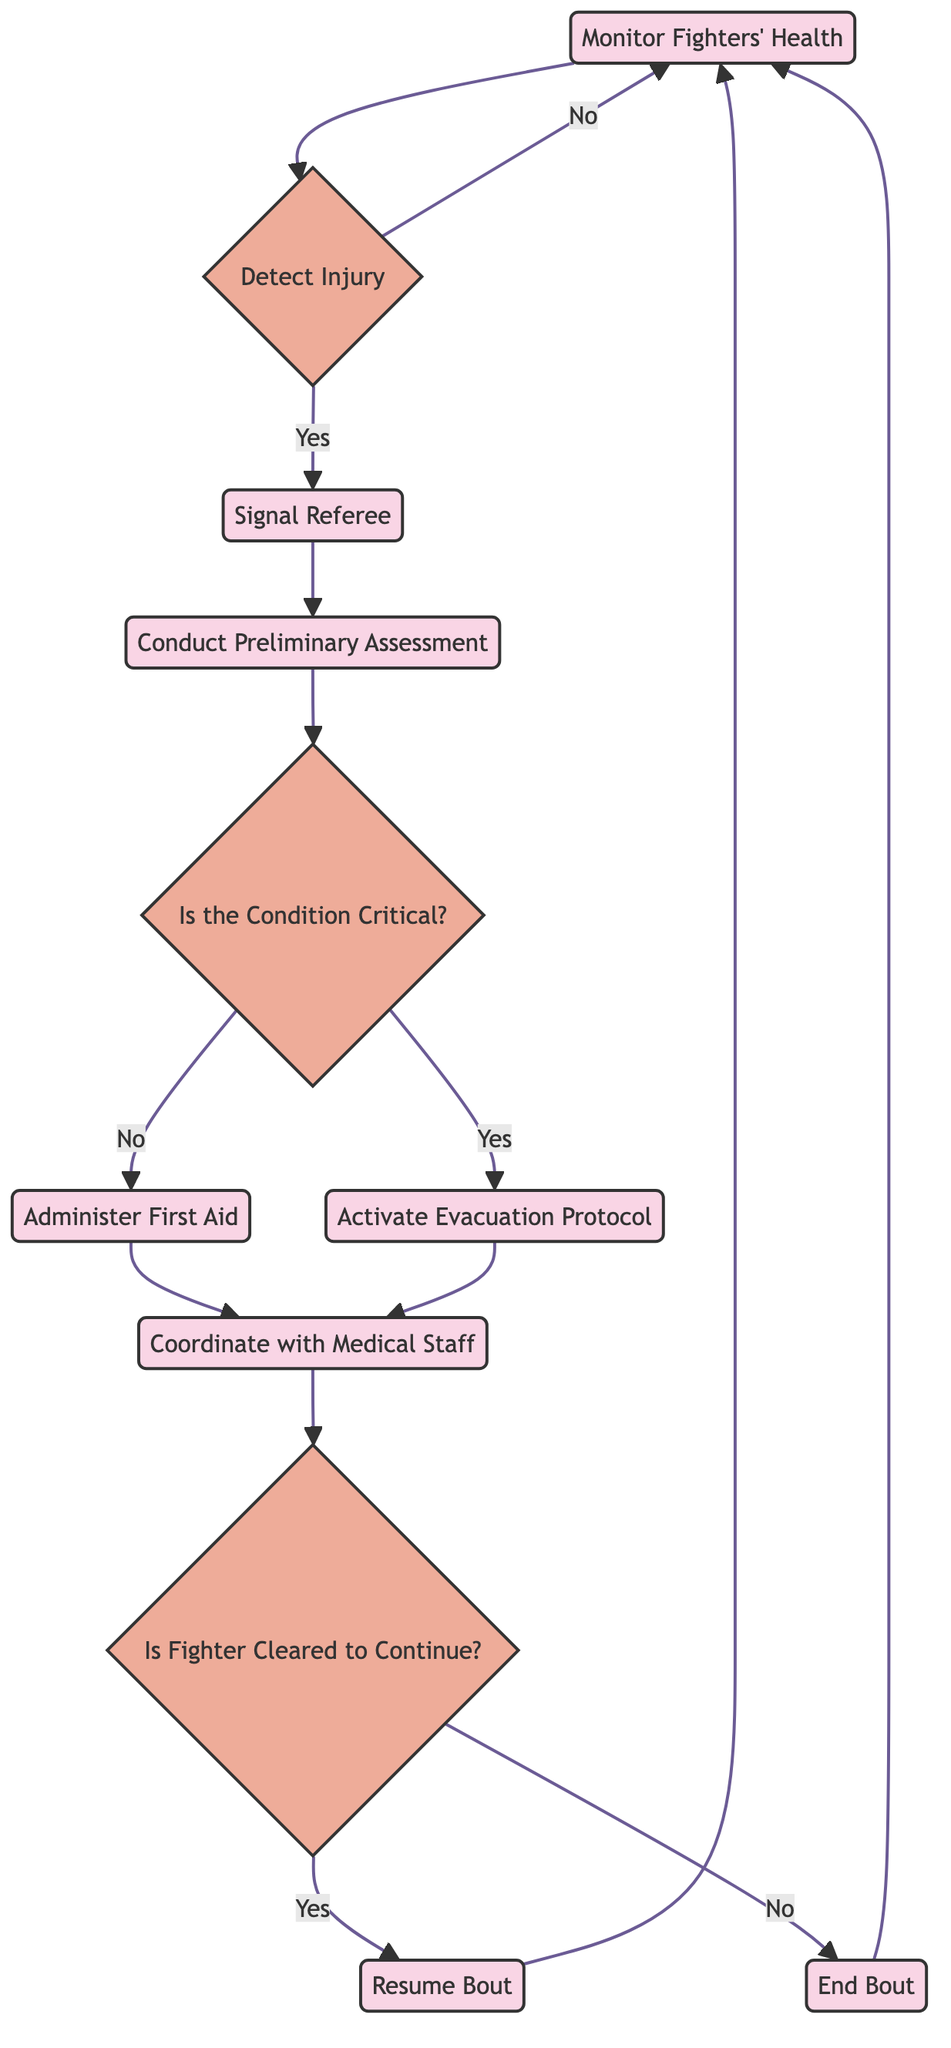What is the first step in the flowchart? The flowchart begins with "Monitor Fighters' Health" as the first process that initiates the sequence of actions.
Answer: Monitor Fighters' Health How many decision points are present in the diagram? The diagram contains three decision points: "Detect Injury," "Is the Condition Critical?", and "Is Fighter Cleared to Continue?"
Answer: 3 What action follows after detecting an injury? After detecting an injury, the next action is to "Signal Referee," indicating that the bout should be paused if an injury is identified.
Answer: Signal Referee What happens if the fighter's condition is not critical? If the condition is not critical, the next step is to "Administer First Aid," providing medical attention to the injured fighter without urgent evacuation.
Answer: Administer First Aid What does the medical staff do while assessing the injured fighter? During the assessment, medical staff "Coordinate with Medical Staff," ensuring they communicate updates about the fighter's condition to other medical personnel.
Answer: Coordinate with Medical Staff If the fighter is not cleared to continue, what is the next action? If the fighter is not cleared to continue, the action taken is to "End Bout," informing the officials to stop the fight.
Answer: End Bout What are the two possible paths after conducting a preliminary assessment? After conducting a preliminary assessment, the two possible paths are either to check if the condition is critical or to administer first aid if it is not critical.
Answer: Check and Administer First Aid How does the flowchart handle a critical injury? If the injury is determined to be critical, the flow leads to activating the evacuation protocol, which involves moving the fighter to a medical facility following emergency procedures.
Answer: Activate Evacuation Protocol What is the last action before returning to the monitoring phase? The last action before returning to the monitoring phase is either to "Resume Bout" if the fighter is cleared or to "End Bout" if they are not cleared.
Answer: Resume Bout or End Bout 